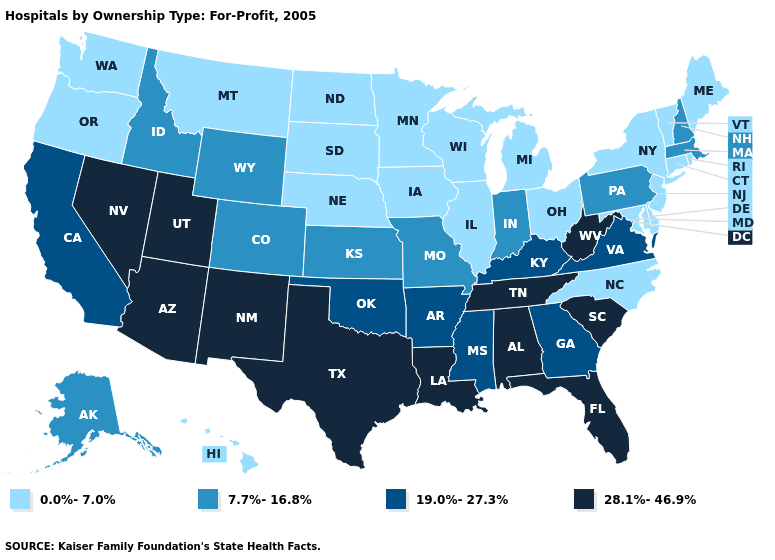Name the states that have a value in the range 0.0%-7.0%?
Be succinct. Connecticut, Delaware, Hawaii, Illinois, Iowa, Maine, Maryland, Michigan, Minnesota, Montana, Nebraska, New Jersey, New York, North Carolina, North Dakota, Ohio, Oregon, Rhode Island, South Dakota, Vermont, Washington, Wisconsin. Does Mississippi have the lowest value in the South?
Concise answer only. No. What is the value of North Carolina?
Answer briefly. 0.0%-7.0%. Does the first symbol in the legend represent the smallest category?
Answer briefly. Yes. What is the value of Idaho?
Be succinct. 7.7%-16.8%. What is the value of Louisiana?
Give a very brief answer. 28.1%-46.9%. Among the states that border New York , which have the lowest value?
Answer briefly. Connecticut, New Jersey, Vermont. Does Oklahoma have the same value as Nevada?
Answer briefly. No. Name the states that have a value in the range 28.1%-46.9%?
Give a very brief answer. Alabama, Arizona, Florida, Louisiana, Nevada, New Mexico, South Carolina, Tennessee, Texas, Utah, West Virginia. What is the value of Connecticut?
Write a very short answer. 0.0%-7.0%. Among the states that border Montana , which have the highest value?
Short answer required. Idaho, Wyoming. How many symbols are there in the legend?
Give a very brief answer. 4. Name the states that have a value in the range 0.0%-7.0%?
Keep it brief. Connecticut, Delaware, Hawaii, Illinois, Iowa, Maine, Maryland, Michigan, Minnesota, Montana, Nebraska, New Jersey, New York, North Carolina, North Dakota, Ohio, Oregon, Rhode Island, South Dakota, Vermont, Washington, Wisconsin. Does the first symbol in the legend represent the smallest category?
Give a very brief answer. Yes. Among the states that border Alabama , which have the highest value?
Answer briefly. Florida, Tennessee. 